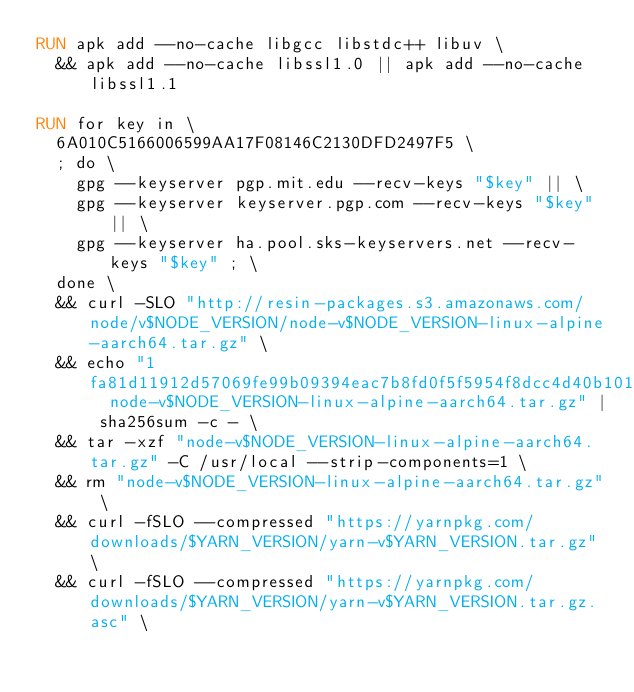Convert code to text. <code><loc_0><loc_0><loc_500><loc_500><_Dockerfile_>RUN apk add --no-cache libgcc libstdc++ libuv \
	&& apk add --no-cache libssl1.0 || apk add --no-cache libssl1.1

RUN for key in \
	6A010C5166006599AA17F08146C2130DFD2497F5 \
	; do \
		gpg --keyserver pgp.mit.edu --recv-keys "$key" || \
		gpg --keyserver keyserver.pgp.com --recv-keys "$key" || \
		gpg --keyserver ha.pool.sks-keyservers.net --recv-keys "$key" ; \
	done \
	&& curl -SLO "http://resin-packages.s3.amazonaws.com/node/v$NODE_VERSION/node-v$NODE_VERSION-linux-alpine-aarch64.tar.gz" \
	&& echo "1fa81d11912d57069fe99b09394eac7b8fd0f5f5954f8dcc4d40b1012794de0b  node-v$NODE_VERSION-linux-alpine-aarch64.tar.gz" | sha256sum -c - \
	&& tar -xzf "node-v$NODE_VERSION-linux-alpine-aarch64.tar.gz" -C /usr/local --strip-components=1 \
	&& rm "node-v$NODE_VERSION-linux-alpine-aarch64.tar.gz" \
	&& curl -fSLO --compressed "https://yarnpkg.com/downloads/$YARN_VERSION/yarn-v$YARN_VERSION.tar.gz" \
	&& curl -fSLO --compressed "https://yarnpkg.com/downloads/$YARN_VERSION/yarn-v$YARN_VERSION.tar.gz.asc" \</code> 